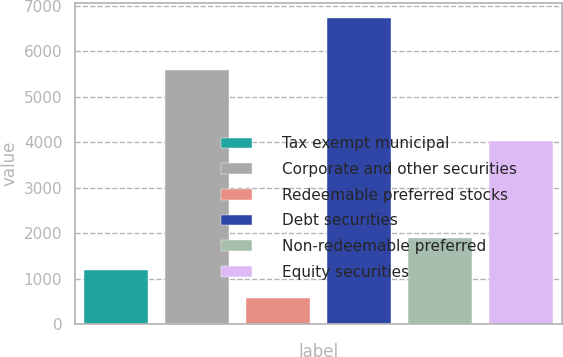<chart> <loc_0><loc_0><loc_500><loc_500><bar_chart><fcel>Tax exempt municipal<fcel>Corporate and other securities<fcel>Redeemable preferred stocks<fcel>Debt securities<fcel>Non-redeemable preferred<fcel>Equity securities<nl><fcel>1180.3<fcel>5597<fcel>564<fcel>6727<fcel>1900<fcel>4018<nl></chart> 